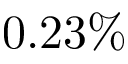Convert formula to latex. <formula><loc_0><loc_0><loc_500><loc_500>0 . 2 3 \%</formula> 